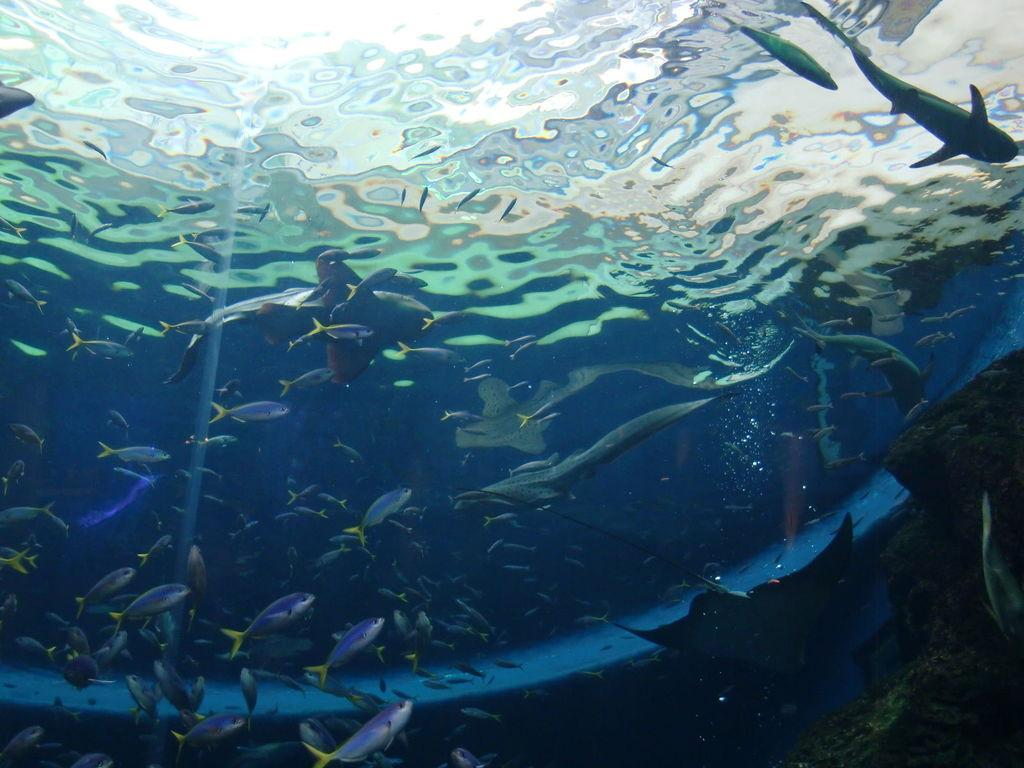What type of animals can be seen in the image? There is a group of fishes in the image. What else is present in the image besides the fishes? There are rocks in the image. Where are the fishes and rocks located? The fishes and rocks are in the water. How many kittens can be seen playing with a foot in the image? There are no kittens or feet present in the image; it features a group of fishes and rocks in the water. What type of lizards can be seen swimming alongside the fishes in the image? There are no lizards present in the image; it only features a group of fishes and rocks in the water. 